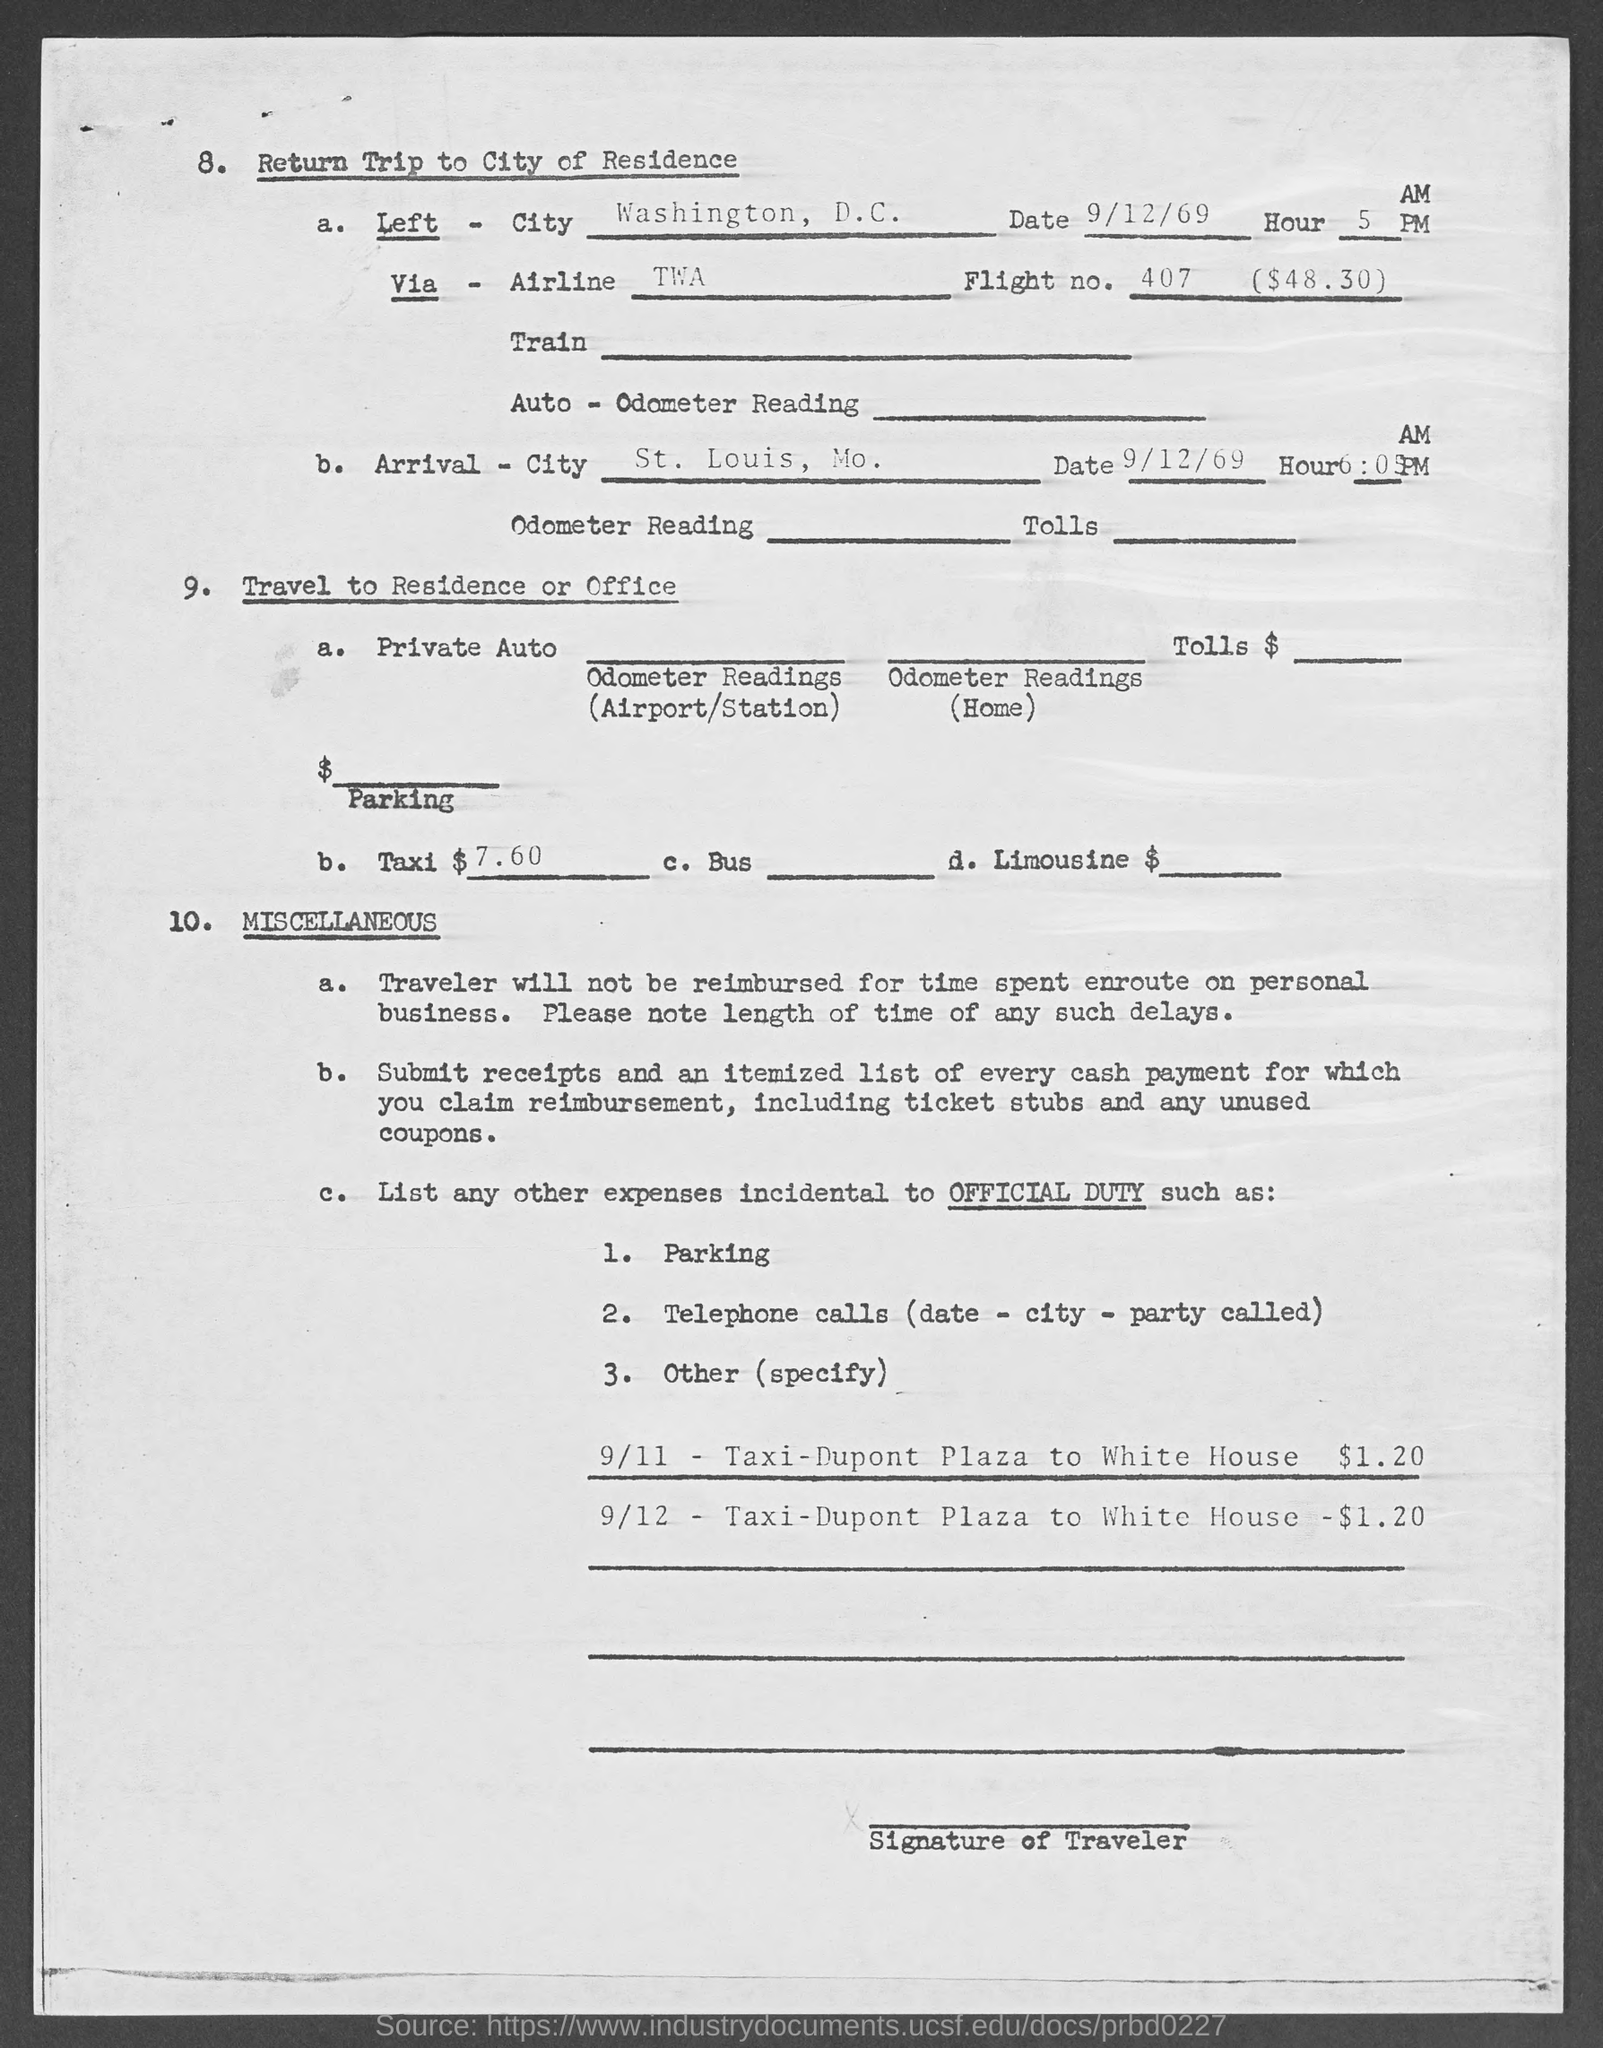Give some essential details in this illustration. The cost of the taxi mentioned in the given page is 7.60. The date of arrival mentioned on the given page is 9/12/69. The left city mentioned in the given page is Washington, D.C. The arrival city mentioned in the given page is St. Louis, Missouri. The flight number mentioned on the given page is 407. 